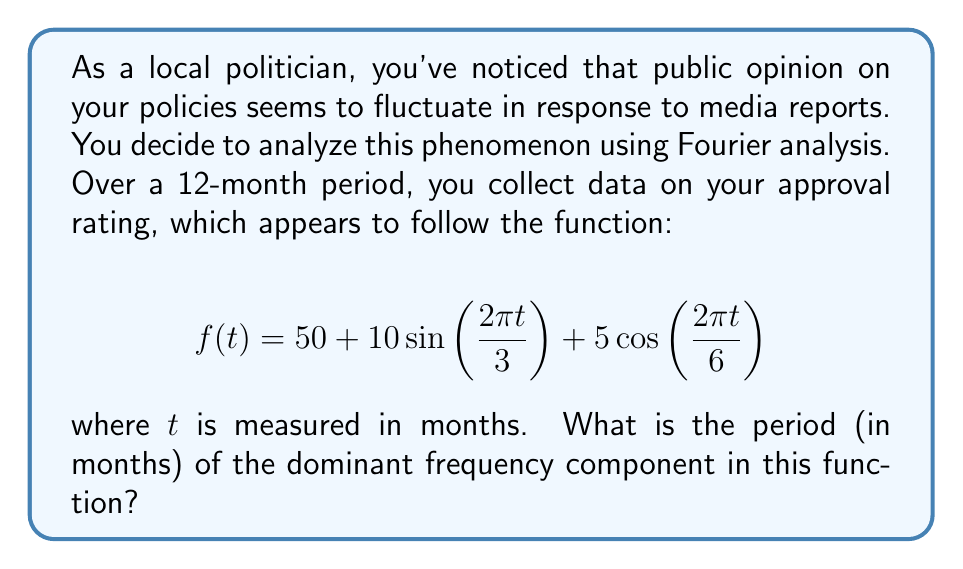Can you answer this question? To find the dominant frequency component and its period, we need to analyze the given function:

$$f(t) = 50 + 10\sin(2\pi t/3) + 5\cos(2\pi t/6)$$

1) First, let's identify the frequency components:
   - The constant term 50 has no frequency.
   - $\sin(2\pi t/3)$ has a frequency of $1/3$ cycles per month.
   - $\cos(2\pi t/6)$ has a frequency of $1/6$ cycles per month.

2) The amplitude of each component indicates its strength:
   - $\sin(2\pi t/3)$ has an amplitude of 10.
   - $\cos(2\pi t/6)$ has an amplitude of 5.

3) The component with the larger amplitude is the dominant one:
   $10\sin(2\pi t/3)$ is the dominant component.

4) The period is the inverse of the frequency:
   Period = $1 / (1/3) = 3$ months

Therefore, the dominant frequency component has a period of 3 months.
Answer: 3 months 